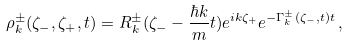<formula> <loc_0><loc_0><loc_500><loc_500>\rho ^ { \pm } _ { k } ( \zeta _ { - } , \zeta _ { + } , t ) = R ^ { \pm } _ { k } ( \zeta _ { - } - \frac { \hbar { k } } { m } t ) e ^ { i k \zeta _ { + } } e ^ { - \Gamma ^ { \pm } _ { k } ( \zeta _ { - } , t ) t } \, ,</formula> 